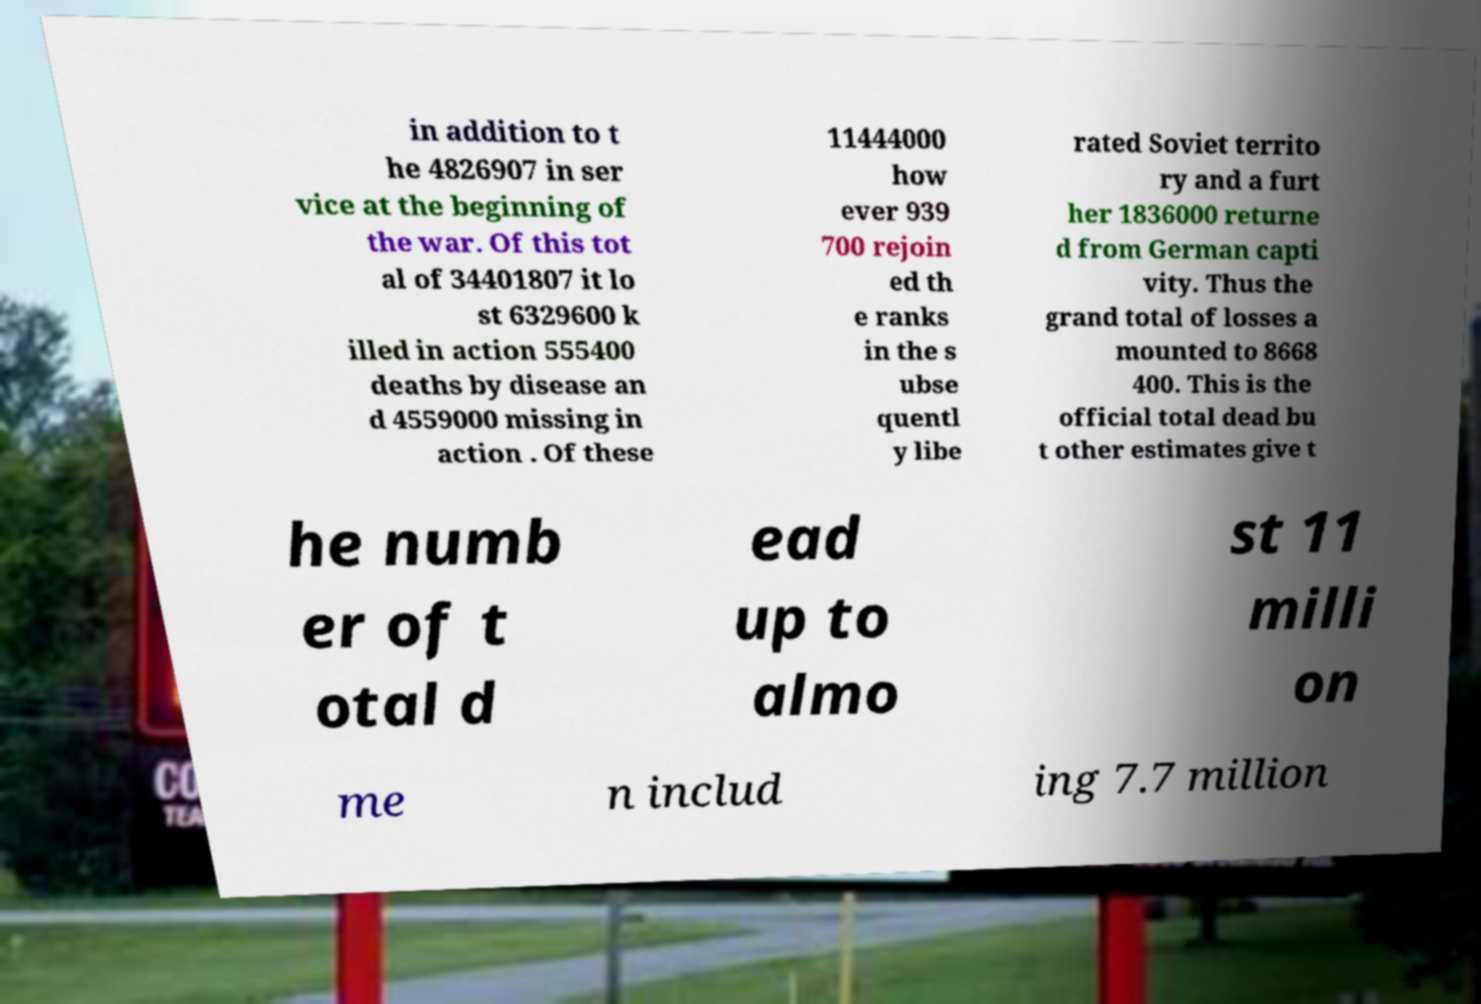For documentation purposes, I need the text within this image transcribed. Could you provide that? in addition to t he 4826907 in ser vice at the beginning of the war. Of this tot al of 34401807 it lo st 6329600 k illed in action 555400 deaths by disease an d 4559000 missing in action . Of these 11444000 how ever 939 700 rejoin ed th e ranks in the s ubse quentl y libe rated Soviet territo ry and a furt her 1836000 returne d from German capti vity. Thus the grand total of losses a mounted to 8668 400. This is the official total dead bu t other estimates give t he numb er of t otal d ead up to almo st 11 milli on me n includ ing 7.7 million 